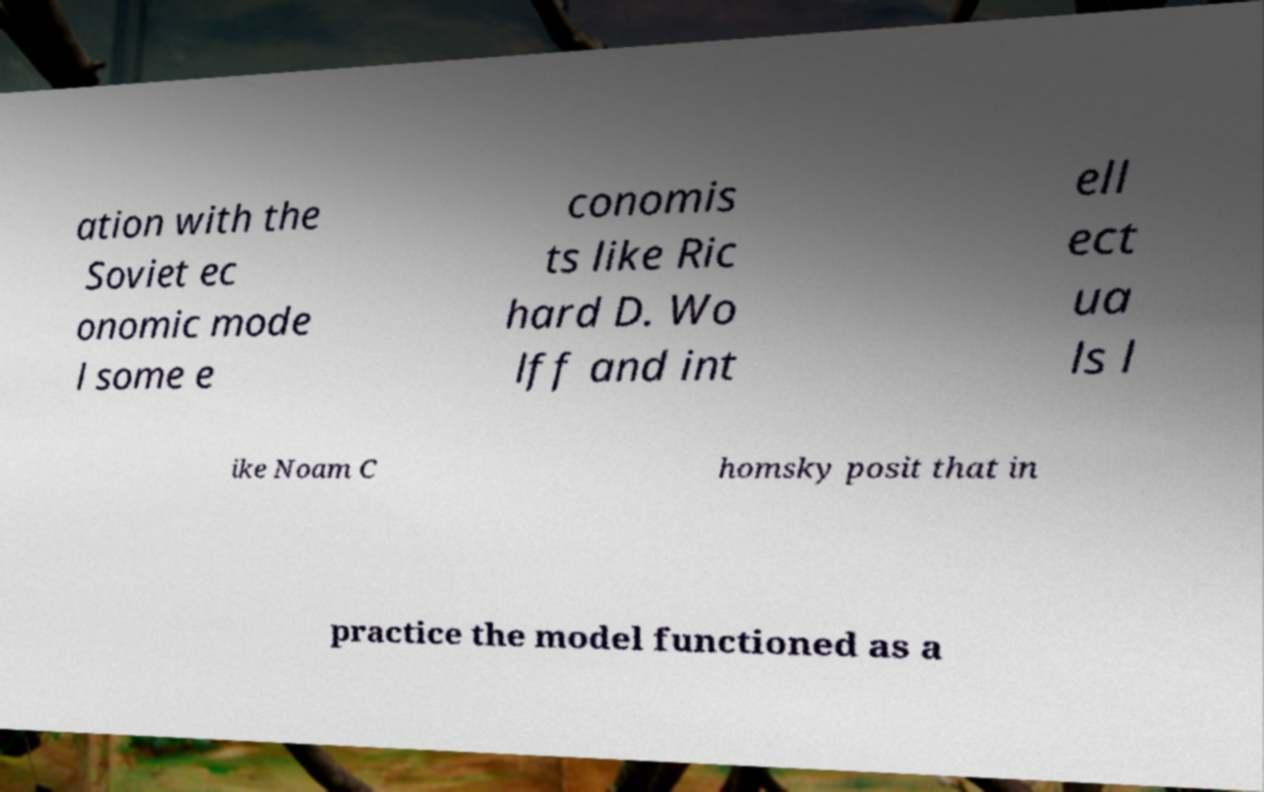Could you extract and type out the text from this image? ation with the Soviet ec onomic mode l some e conomis ts like Ric hard D. Wo lff and int ell ect ua ls l ike Noam C homsky posit that in practice the model functioned as a 